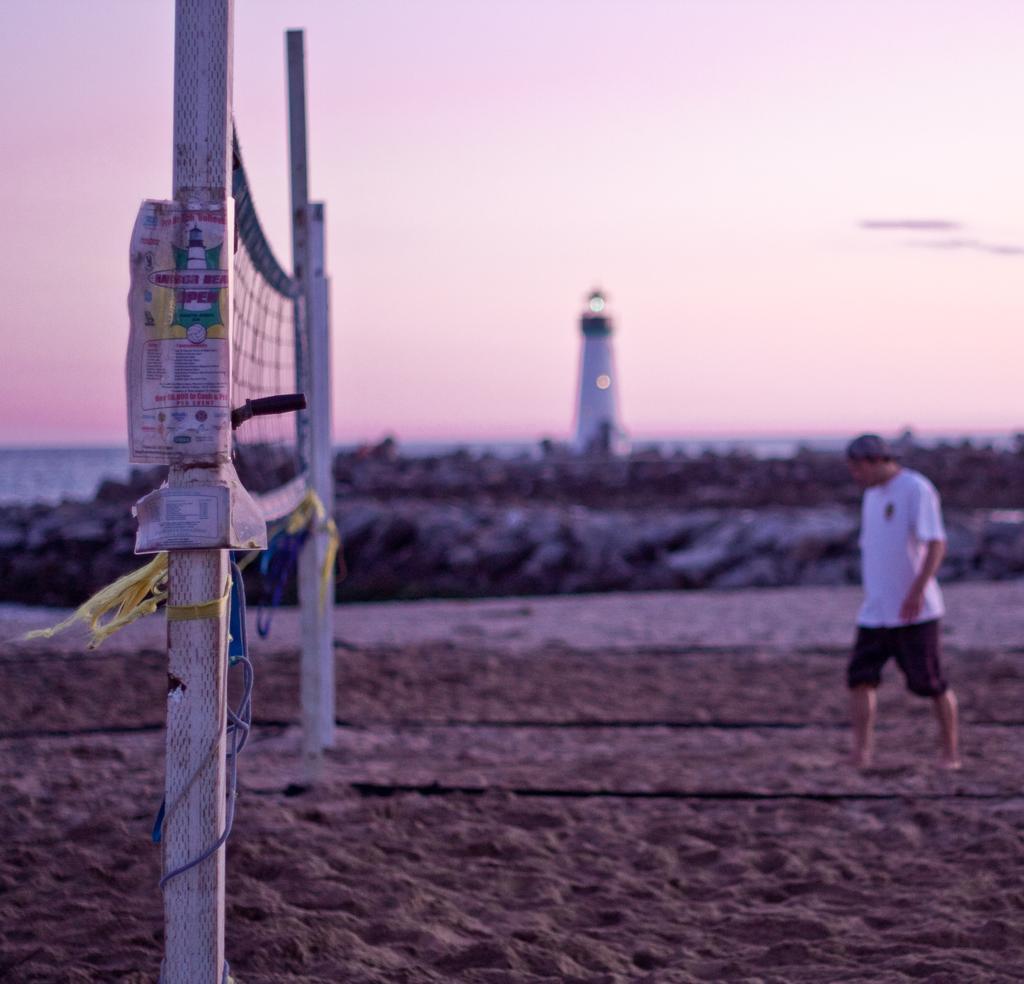In one or two sentences, can you explain what this image depicts? In this image we can see a person standing on the ground. To the left side of the image we can see two poles with a net. In the background, we can see a lighthouse, a group of rocks and the sky. 